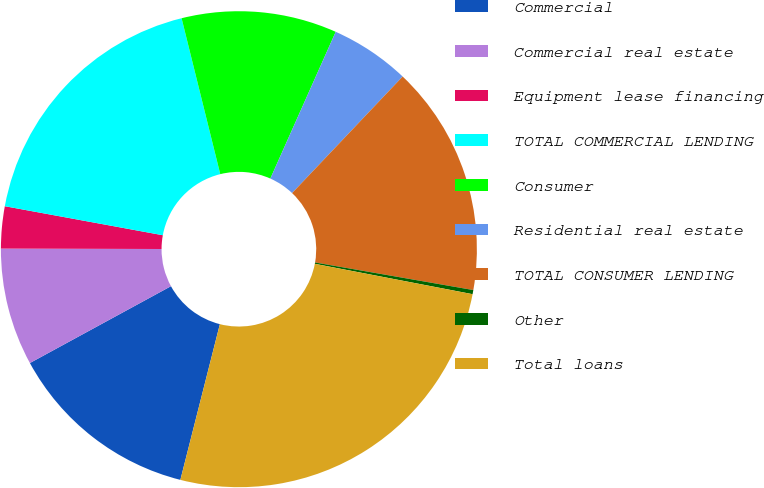Convert chart. <chart><loc_0><loc_0><loc_500><loc_500><pie_chart><fcel>Commercial<fcel>Commercial real estate<fcel>Equipment lease financing<fcel>TOTAL COMMERCIAL LENDING<fcel>Consumer<fcel>Residential real estate<fcel>TOTAL CONSUMER LENDING<fcel>Other<fcel>Total loans<nl><fcel>13.11%<fcel>7.98%<fcel>2.85%<fcel>18.24%<fcel>10.54%<fcel>5.41%<fcel>15.67%<fcel>0.28%<fcel>25.93%<nl></chart> 